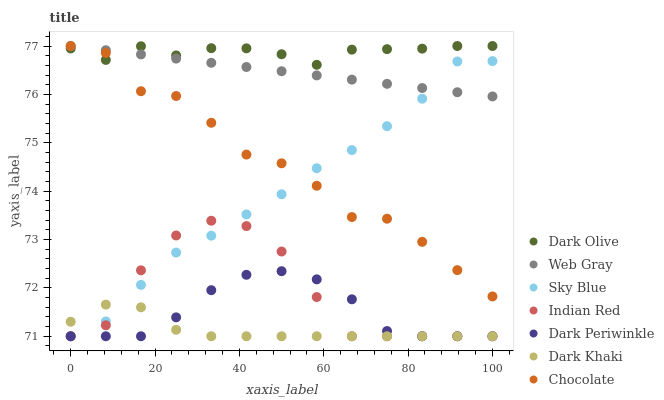Does Dark Khaki have the minimum area under the curve?
Answer yes or no. Yes. Does Dark Olive have the maximum area under the curve?
Answer yes or no. Yes. Does Chocolate have the minimum area under the curve?
Answer yes or no. No. Does Chocolate have the maximum area under the curve?
Answer yes or no. No. Is Web Gray the smoothest?
Answer yes or no. Yes. Is Chocolate the roughest?
Answer yes or no. Yes. Is Dark Olive the smoothest?
Answer yes or no. No. Is Dark Olive the roughest?
Answer yes or no. No. Does Dark Khaki have the lowest value?
Answer yes or no. Yes. Does Chocolate have the lowest value?
Answer yes or no. No. Does Chocolate have the highest value?
Answer yes or no. Yes. Does Dark Khaki have the highest value?
Answer yes or no. No. Is Sky Blue less than Dark Olive?
Answer yes or no. Yes. Is Web Gray greater than Indian Red?
Answer yes or no. Yes. Does Sky Blue intersect Indian Red?
Answer yes or no. Yes. Is Sky Blue less than Indian Red?
Answer yes or no. No. Is Sky Blue greater than Indian Red?
Answer yes or no. No. Does Sky Blue intersect Dark Olive?
Answer yes or no. No. 